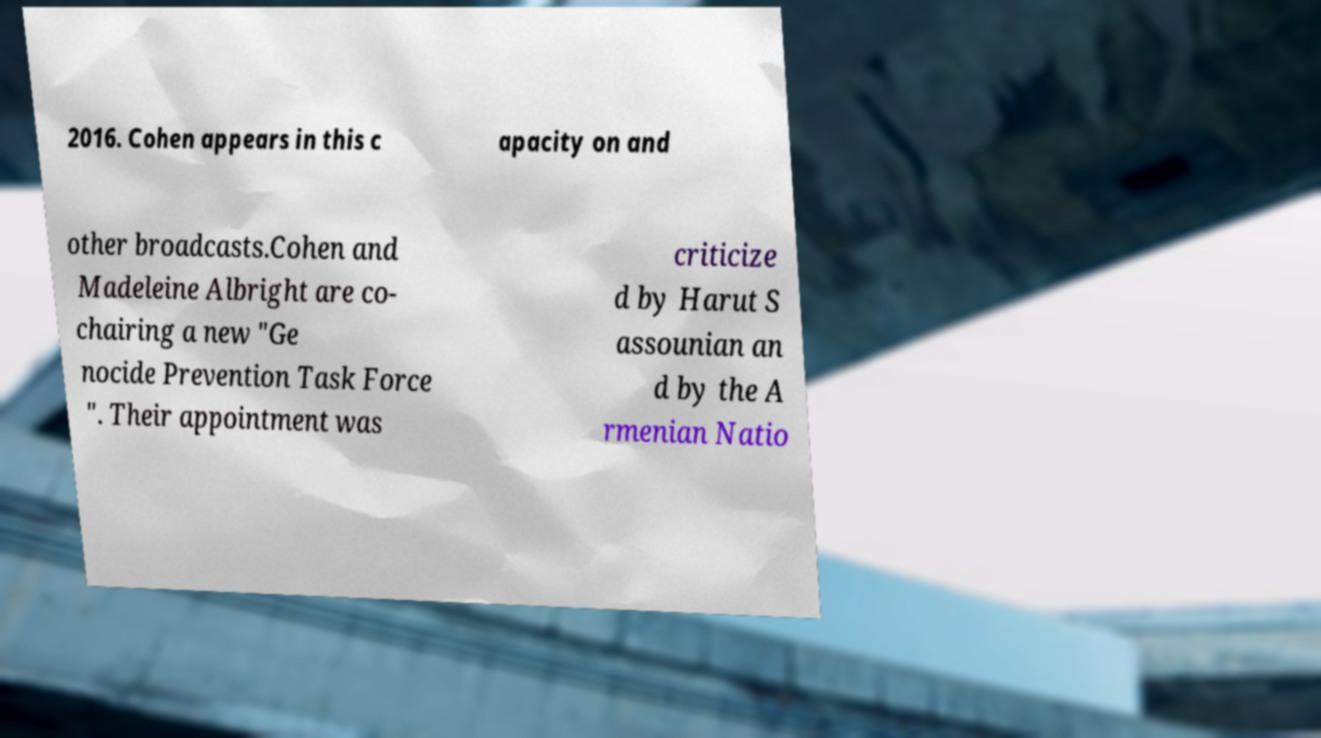For documentation purposes, I need the text within this image transcribed. Could you provide that? 2016. Cohen appears in this c apacity on and other broadcasts.Cohen and Madeleine Albright are co- chairing a new "Ge nocide Prevention Task Force ". Their appointment was criticize d by Harut S assounian an d by the A rmenian Natio 